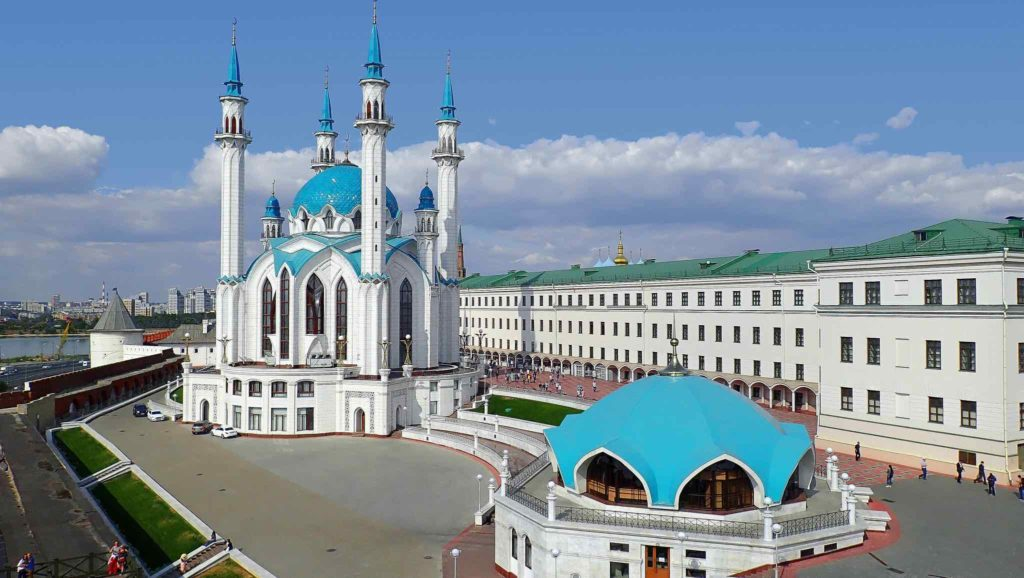Imagine a festival taking place in this scene. What kind of activities and decorations would you expect? Imagining a festival at the Kazan Kremlin, one could expect a lively and vibrant atmosphere. The lush green lawns could be dotted with colorful tents and stalls showcasing local crafts, foods, and traditional garments. The Kul Sharif Mosque and Presidential Palace would be adorned with festive lights and decorations, perhaps featuring traditional Tatar patterns and symbols. Activities might include folk music and dance performances, historical reenactments, and cultural workshops where visitors can learn about Tatar heritage. The air would be filled with the tempting aromas of local delicacies being prepared, and the sounds of laughter and music would create an unforgettable festive experience. That sounds so lively! Can you tell me more about what kinds of food might be available at the festival? At such a festival, the food stalls would offer a delectable array of Tatar cuisine that showcases rich flavors and traditional recipes. You might find Echpochmak, a popular Tatar pastry filled with meat, potatoes, and onions. Chak-Chak, a traditional sweet made from dough balls coated in honey, would satisfy those with a sweet tooth. Other savory options could include Peremech, which are deep-fried dough filled with minced meat, and Azu, a spiced meat stew with pickles and potatoes. The beverage options might feature traditional Tatar herbal teas and perhaps some locally brewed kvass, a fermented bread drink. Each dish would tell a story of the region’s culinary heritage, offering festival-goers a true taste of Tatar culture. 